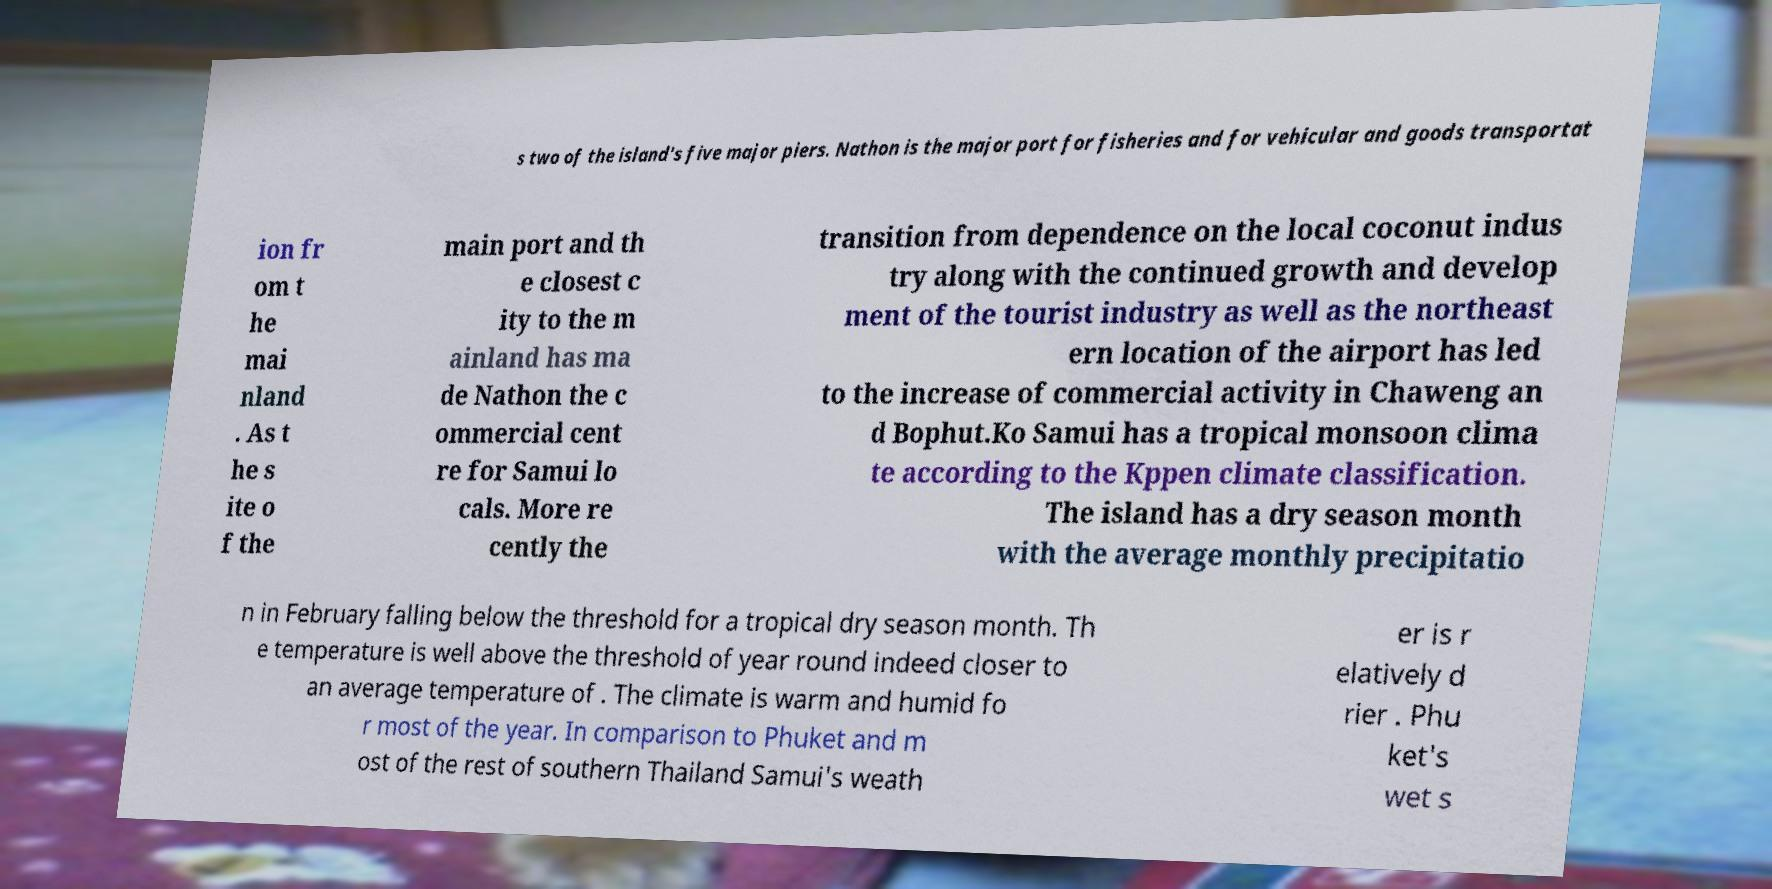What messages or text are displayed in this image? I need them in a readable, typed format. s two of the island's five major piers. Nathon is the major port for fisheries and for vehicular and goods transportat ion fr om t he mai nland . As t he s ite o f the main port and th e closest c ity to the m ainland has ma de Nathon the c ommercial cent re for Samui lo cals. More re cently the transition from dependence on the local coconut indus try along with the continued growth and develop ment of the tourist industry as well as the northeast ern location of the airport has led to the increase of commercial activity in Chaweng an d Bophut.Ko Samui has a tropical monsoon clima te according to the Kppen climate classification. The island has a dry season month with the average monthly precipitatio n in February falling below the threshold for a tropical dry season month. Th e temperature is well above the threshold of year round indeed closer to an average temperature of . The climate is warm and humid fo r most of the year. In comparison to Phuket and m ost of the rest of southern Thailand Samui's weath er is r elatively d rier . Phu ket's wet s 